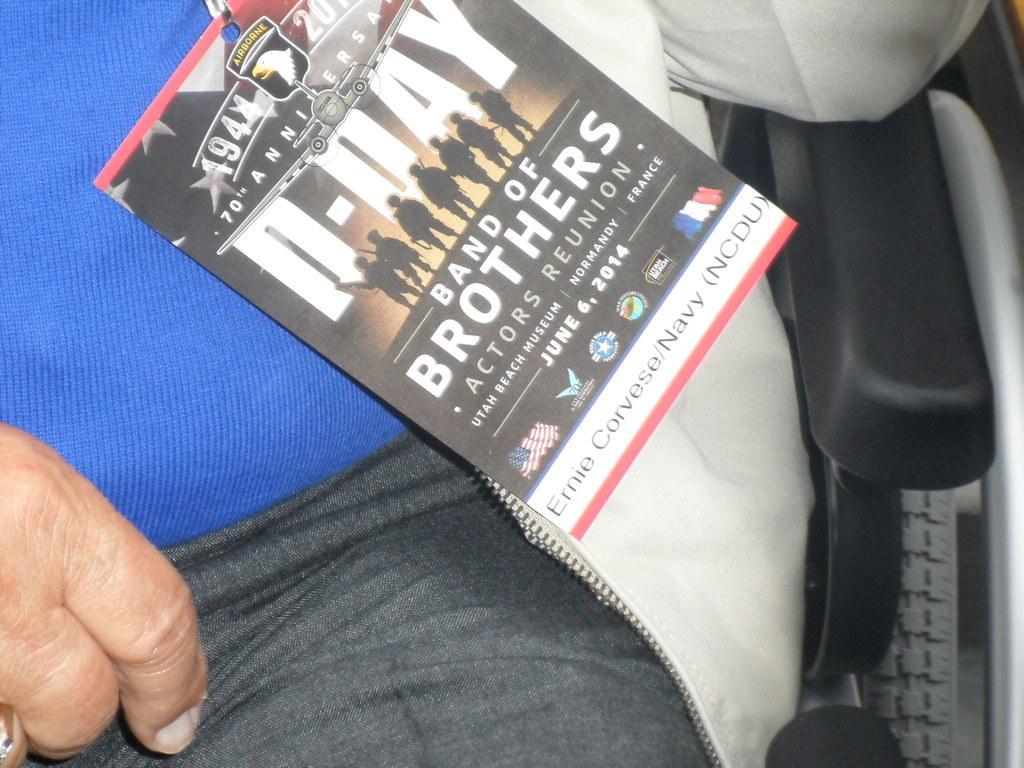Can you describe this image briefly? In this image, we can see a person sitting on the chair, on the person, we can see a paper, on the paper, we can see some pictures and text. 